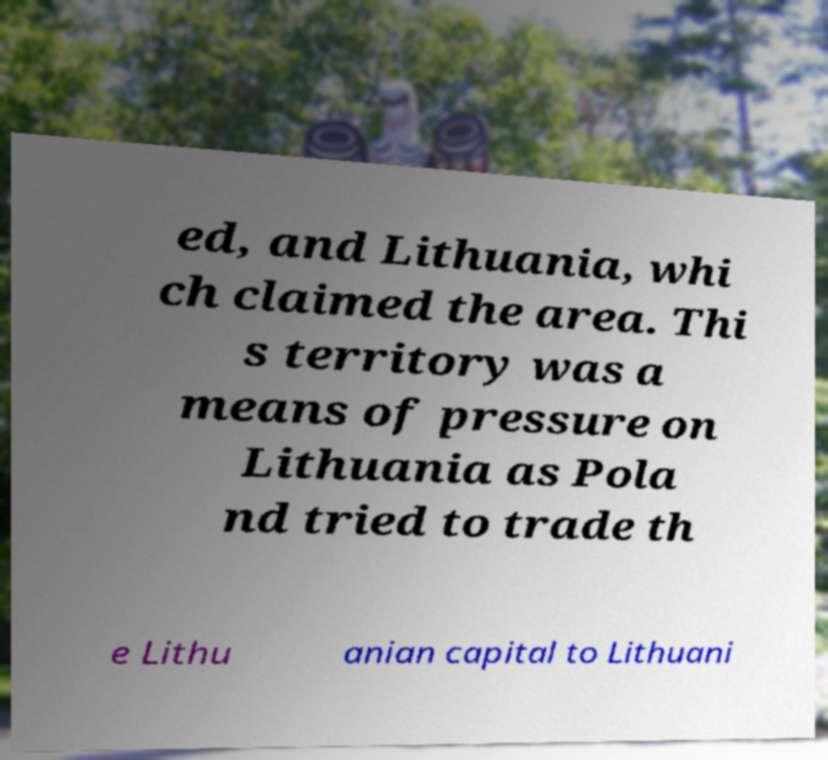What messages or text are displayed in this image? I need them in a readable, typed format. ed, and Lithuania, whi ch claimed the area. Thi s territory was a means of pressure on Lithuania as Pola nd tried to trade th e Lithu anian capital to Lithuani 